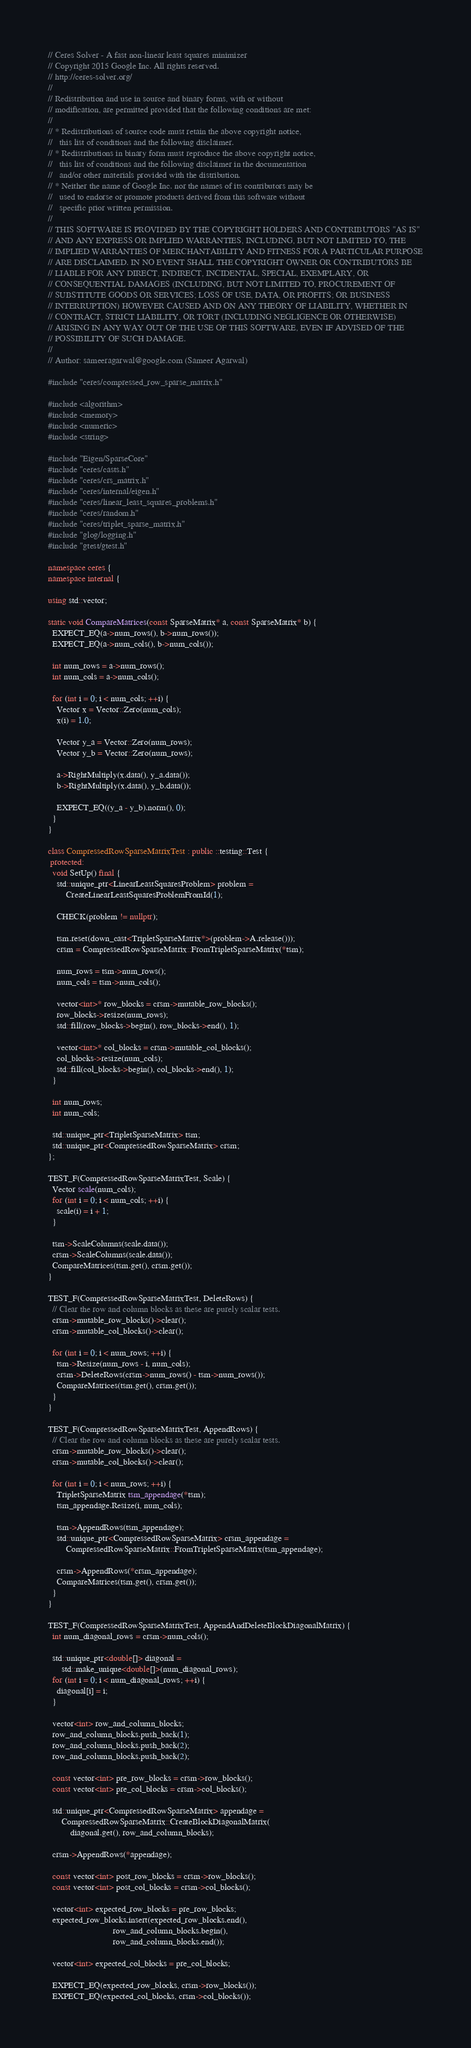<code> <loc_0><loc_0><loc_500><loc_500><_C++_>// Ceres Solver - A fast non-linear least squares minimizer
// Copyright 2015 Google Inc. All rights reserved.
// http://ceres-solver.org/
//
// Redistribution and use in source and binary forms, with or without
// modification, are permitted provided that the following conditions are met:
//
// * Redistributions of source code must retain the above copyright notice,
//   this list of conditions and the following disclaimer.
// * Redistributions in binary form must reproduce the above copyright notice,
//   this list of conditions and the following disclaimer in the documentation
//   and/or other materials provided with the distribution.
// * Neither the name of Google Inc. nor the names of its contributors may be
//   used to endorse or promote products derived from this software without
//   specific prior written permission.
//
// THIS SOFTWARE IS PROVIDED BY THE COPYRIGHT HOLDERS AND CONTRIBUTORS "AS IS"
// AND ANY EXPRESS OR IMPLIED WARRANTIES, INCLUDING, BUT NOT LIMITED TO, THE
// IMPLIED WARRANTIES OF MERCHANTABILITY AND FITNESS FOR A PARTICULAR PURPOSE
// ARE DISCLAIMED. IN NO EVENT SHALL THE COPYRIGHT OWNER OR CONTRIBUTORS BE
// LIABLE FOR ANY DIRECT, INDIRECT, INCIDENTAL, SPECIAL, EXEMPLARY, OR
// CONSEQUENTIAL DAMAGES (INCLUDING, BUT NOT LIMITED TO, PROCUREMENT OF
// SUBSTITUTE GOODS OR SERVICES; LOSS OF USE, DATA, OR PROFITS; OR BUSINESS
// INTERRUPTION) HOWEVER CAUSED AND ON ANY THEORY OF LIABILITY, WHETHER IN
// CONTRACT, STRICT LIABILITY, OR TORT (INCLUDING NEGLIGENCE OR OTHERWISE)
// ARISING IN ANY WAY OUT OF THE USE OF THIS SOFTWARE, EVEN IF ADVISED OF THE
// POSSIBILITY OF SUCH DAMAGE.
//
// Author: sameeragarwal@google.com (Sameer Agarwal)

#include "ceres/compressed_row_sparse_matrix.h"

#include <algorithm>
#include <memory>
#include <numeric>
#include <string>

#include "Eigen/SparseCore"
#include "ceres/casts.h"
#include "ceres/crs_matrix.h"
#include "ceres/internal/eigen.h"
#include "ceres/linear_least_squares_problems.h"
#include "ceres/random.h"
#include "ceres/triplet_sparse_matrix.h"
#include "glog/logging.h"
#include "gtest/gtest.h"

namespace ceres {
namespace internal {

using std::vector;

static void CompareMatrices(const SparseMatrix* a, const SparseMatrix* b) {
  EXPECT_EQ(a->num_rows(), b->num_rows());
  EXPECT_EQ(a->num_cols(), b->num_cols());

  int num_rows = a->num_rows();
  int num_cols = a->num_cols();

  for (int i = 0; i < num_cols; ++i) {
    Vector x = Vector::Zero(num_cols);
    x(i) = 1.0;

    Vector y_a = Vector::Zero(num_rows);
    Vector y_b = Vector::Zero(num_rows);

    a->RightMultiply(x.data(), y_a.data());
    b->RightMultiply(x.data(), y_b.data());

    EXPECT_EQ((y_a - y_b).norm(), 0);
  }
}

class CompressedRowSparseMatrixTest : public ::testing::Test {
 protected:
  void SetUp() final {
    std::unique_ptr<LinearLeastSquaresProblem> problem =
        CreateLinearLeastSquaresProblemFromId(1);

    CHECK(problem != nullptr);

    tsm.reset(down_cast<TripletSparseMatrix*>(problem->A.release()));
    crsm = CompressedRowSparseMatrix::FromTripletSparseMatrix(*tsm);

    num_rows = tsm->num_rows();
    num_cols = tsm->num_cols();

    vector<int>* row_blocks = crsm->mutable_row_blocks();
    row_blocks->resize(num_rows);
    std::fill(row_blocks->begin(), row_blocks->end(), 1);

    vector<int>* col_blocks = crsm->mutable_col_blocks();
    col_blocks->resize(num_cols);
    std::fill(col_blocks->begin(), col_blocks->end(), 1);
  }

  int num_rows;
  int num_cols;

  std::unique_ptr<TripletSparseMatrix> tsm;
  std::unique_ptr<CompressedRowSparseMatrix> crsm;
};

TEST_F(CompressedRowSparseMatrixTest, Scale) {
  Vector scale(num_cols);
  for (int i = 0; i < num_cols; ++i) {
    scale(i) = i + 1;
  }

  tsm->ScaleColumns(scale.data());
  crsm->ScaleColumns(scale.data());
  CompareMatrices(tsm.get(), crsm.get());
}

TEST_F(CompressedRowSparseMatrixTest, DeleteRows) {
  // Clear the row and column blocks as these are purely scalar tests.
  crsm->mutable_row_blocks()->clear();
  crsm->mutable_col_blocks()->clear();

  for (int i = 0; i < num_rows; ++i) {
    tsm->Resize(num_rows - i, num_cols);
    crsm->DeleteRows(crsm->num_rows() - tsm->num_rows());
    CompareMatrices(tsm.get(), crsm.get());
  }
}

TEST_F(CompressedRowSparseMatrixTest, AppendRows) {
  // Clear the row and column blocks as these are purely scalar tests.
  crsm->mutable_row_blocks()->clear();
  crsm->mutable_col_blocks()->clear();

  for (int i = 0; i < num_rows; ++i) {
    TripletSparseMatrix tsm_appendage(*tsm);
    tsm_appendage.Resize(i, num_cols);

    tsm->AppendRows(tsm_appendage);
    std::unique_ptr<CompressedRowSparseMatrix> crsm_appendage =
        CompressedRowSparseMatrix::FromTripletSparseMatrix(tsm_appendage);

    crsm->AppendRows(*crsm_appendage);
    CompareMatrices(tsm.get(), crsm.get());
  }
}

TEST_F(CompressedRowSparseMatrixTest, AppendAndDeleteBlockDiagonalMatrix) {
  int num_diagonal_rows = crsm->num_cols();

  std::unique_ptr<double[]> diagonal =
      std::make_unique<double[]>(num_diagonal_rows);
  for (int i = 0; i < num_diagonal_rows; ++i) {
    diagonal[i] = i;
  }

  vector<int> row_and_column_blocks;
  row_and_column_blocks.push_back(1);
  row_and_column_blocks.push_back(2);
  row_and_column_blocks.push_back(2);

  const vector<int> pre_row_blocks = crsm->row_blocks();
  const vector<int> pre_col_blocks = crsm->col_blocks();

  std::unique_ptr<CompressedRowSparseMatrix> appendage =
      CompressedRowSparseMatrix::CreateBlockDiagonalMatrix(
          diagonal.get(), row_and_column_blocks);

  crsm->AppendRows(*appendage);

  const vector<int> post_row_blocks = crsm->row_blocks();
  const vector<int> post_col_blocks = crsm->col_blocks();

  vector<int> expected_row_blocks = pre_row_blocks;
  expected_row_blocks.insert(expected_row_blocks.end(),
                             row_and_column_blocks.begin(),
                             row_and_column_blocks.end());

  vector<int> expected_col_blocks = pre_col_blocks;

  EXPECT_EQ(expected_row_blocks, crsm->row_blocks());
  EXPECT_EQ(expected_col_blocks, crsm->col_blocks());
</code> 